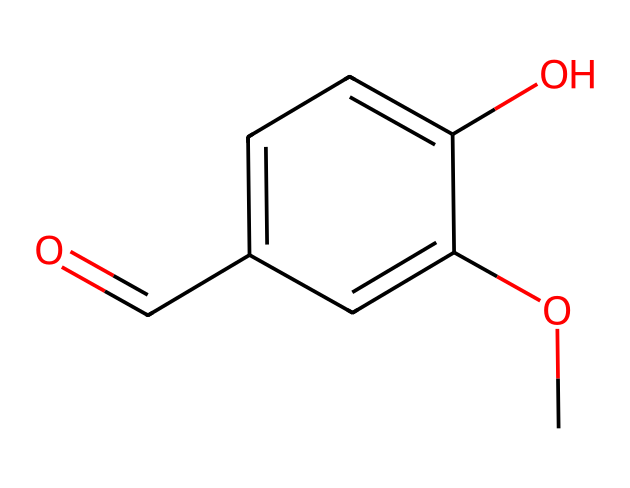What is the IUPAC name of this compound? The chemical structure containing a hydroxyl group (-OH) and a methoxy group (-OCH3) attached to a benzene ring, along with an aldehyde functional group, indicates that the IUPAC name is 4-hydroxy-3-methoxybenzaldehyde.
Answer: 4-hydroxy-3-methoxybenzaldehyde How many carbon atoms are in the structure? Counting the carbon atoms in the structure, there are six in the benzene ring and one from the aldehyde functional group, totaling up to seven carbon atoms.
Answer: 7 What type of functional groups are present in this compound? The structure includes three functional groups: a hydroxyl group (-OH), a methoxy group (-OCH3), and an aldehyde group (-CHO).
Answer: hydroxyl, methoxy, aldehyde What is the formula of this compound? By analyzing the counts of each element in the structure, there are 8 carbon (C), 8 hydrogen (H), and 3 oxygen (O) atoms, giving the molecular formula C8H8O3.
Answer: C8H8O3 Is this compound soluble in water? Due to the presence of the hydroxyl group (-OH), which can form hydrogen bonds with water, this compound is generally considered soluble in water.
Answer: soluble How does the presence of the methoxy group affect the compound's flavor profile? The methoxy group enhances the sweetness and aromatic notes of the flavor profile, which is characteristic of vanillin, making it more appealing in liqueurs and desserts.
Answer: enhances sweetness What state of matter is vanillin at room temperature? Vanillin is typically solid at room temperature, as it has a crystalline structure under normal environmental conditions.
Answer: solid 